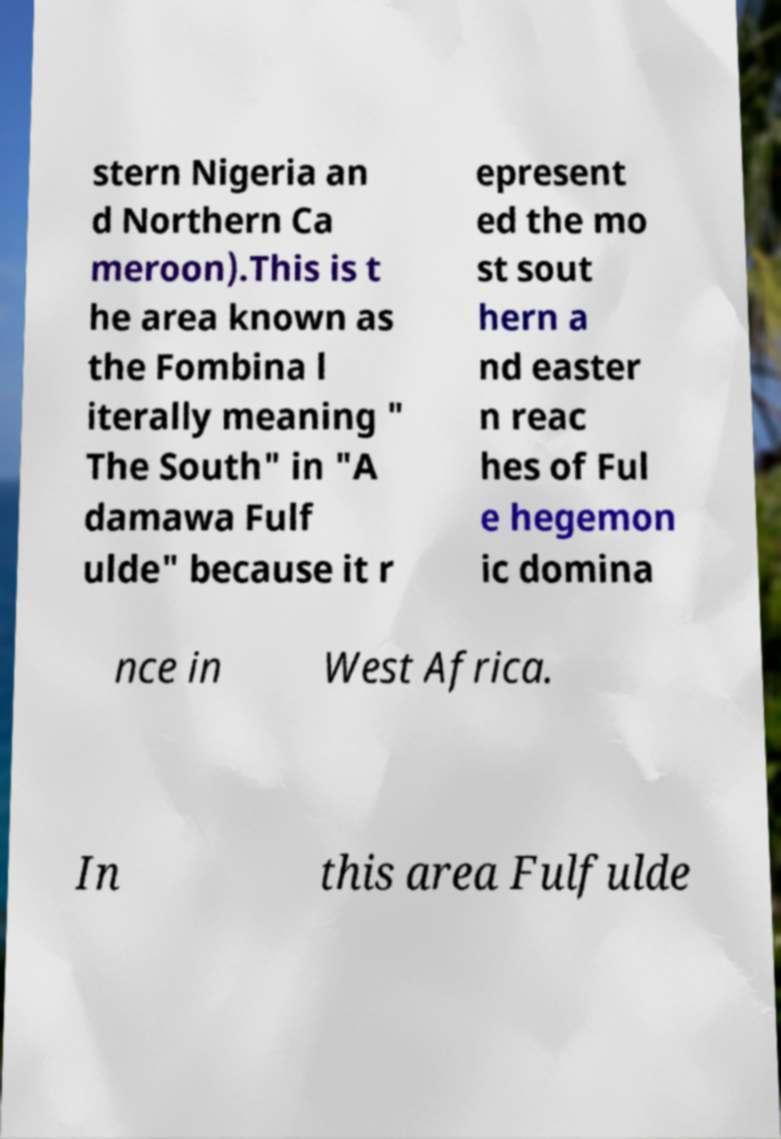Can you read and provide the text displayed in the image?This photo seems to have some interesting text. Can you extract and type it out for me? stern Nigeria an d Northern Ca meroon).This is t he area known as the Fombina l iterally meaning " The South" in "A damawa Fulf ulde" because it r epresent ed the mo st sout hern a nd easter n reac hes of Ful e hegemon ic domina nce in West Africa. In this area Fulfulde 